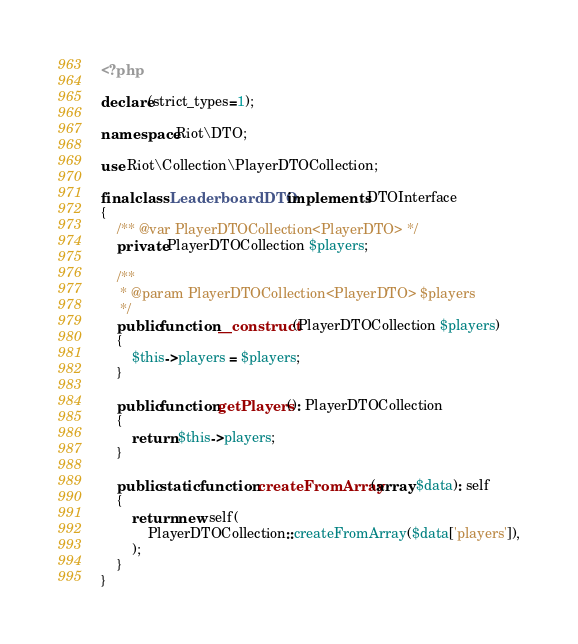<code> <loc_0><loc_0><loc_500><loc_500><_PHP_><?php

declare(strict_types=1);

namespace Riot\DTO;

use Riot\Collection\PlayerDTOCollection;

final class LeaderboardDTO implements DTOInterface
{
    /** @var PlayerDTOCollection<PlayerDTO> */
    private PlayerDTOCollection $players;

    /**
     * @param PlayerDTOCollection<PlayerDTO> $players
     */
    public function __construct(PlayerDTOCollection $players)
    {
        $this->players = $players;
    }

    public function getPlayers(): PlayerDTOCollection
    {
        return $this->players;
    }

    public static function createFromArray(array $data): self
    {
        return new self(
            PlayerDTOCollection::createFromArray($data['players']),
        );
    }
}
</code> 